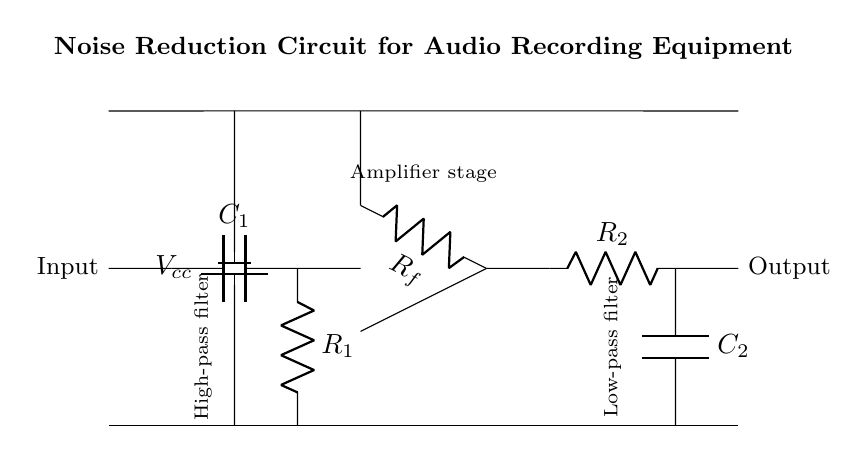What is the main purpose of this circuit? The main purpose is noise reduction for audio recording. This is deduced from the title of the circuit, which explicitly states its function.
Answer: noise reduction for audio recording What type of filter is indicated at the start of the circuit? The first filter in the circuit is a high-pass filter, as labeled in the diagram. This type of filter allows high-frequency signals to pass while attenuating low-frequency signals.
Answer: high-pass filter What component value is represented by C1? C1 is a capacitor, as indicated in the diagram. The exact value is not specified in the diagram but is critical for determining the cutoff frequency of the high-pass filter.
Answer: capacitor How many resistors are present in the circuit? The circuit contains three resistors: R1, R_f, and R2, as shown in the diagram. Each resistor has distinct roles in the high-pass filter, amplifier stage, and low-pass filter.
Answer: three What does the notation V_cc represent? V_cc refers to the voltage supply for the circuit, explicitly labeled in the circuit. This voltage powers the op-amp and other active components in the circuit.
Answer: voltage supply Why is a low-pass filter used in this circuit? A low-pass filter is employed to remove high-frequency noise from the amplified audio signal. This function is essential for delivering clearer audio in recordings, particularly relevant in a quiet environment like a chess tournament.
Answer: to remove high-frequency noise What is the role of the operational amplifier in this design? The operational amplifier amplifies the input signal to improve its strength before processing it through the filters. Its placement in the circuit is crucial for enhancing the signal-to-noise ratio.
Answer: amplifies the input signal 